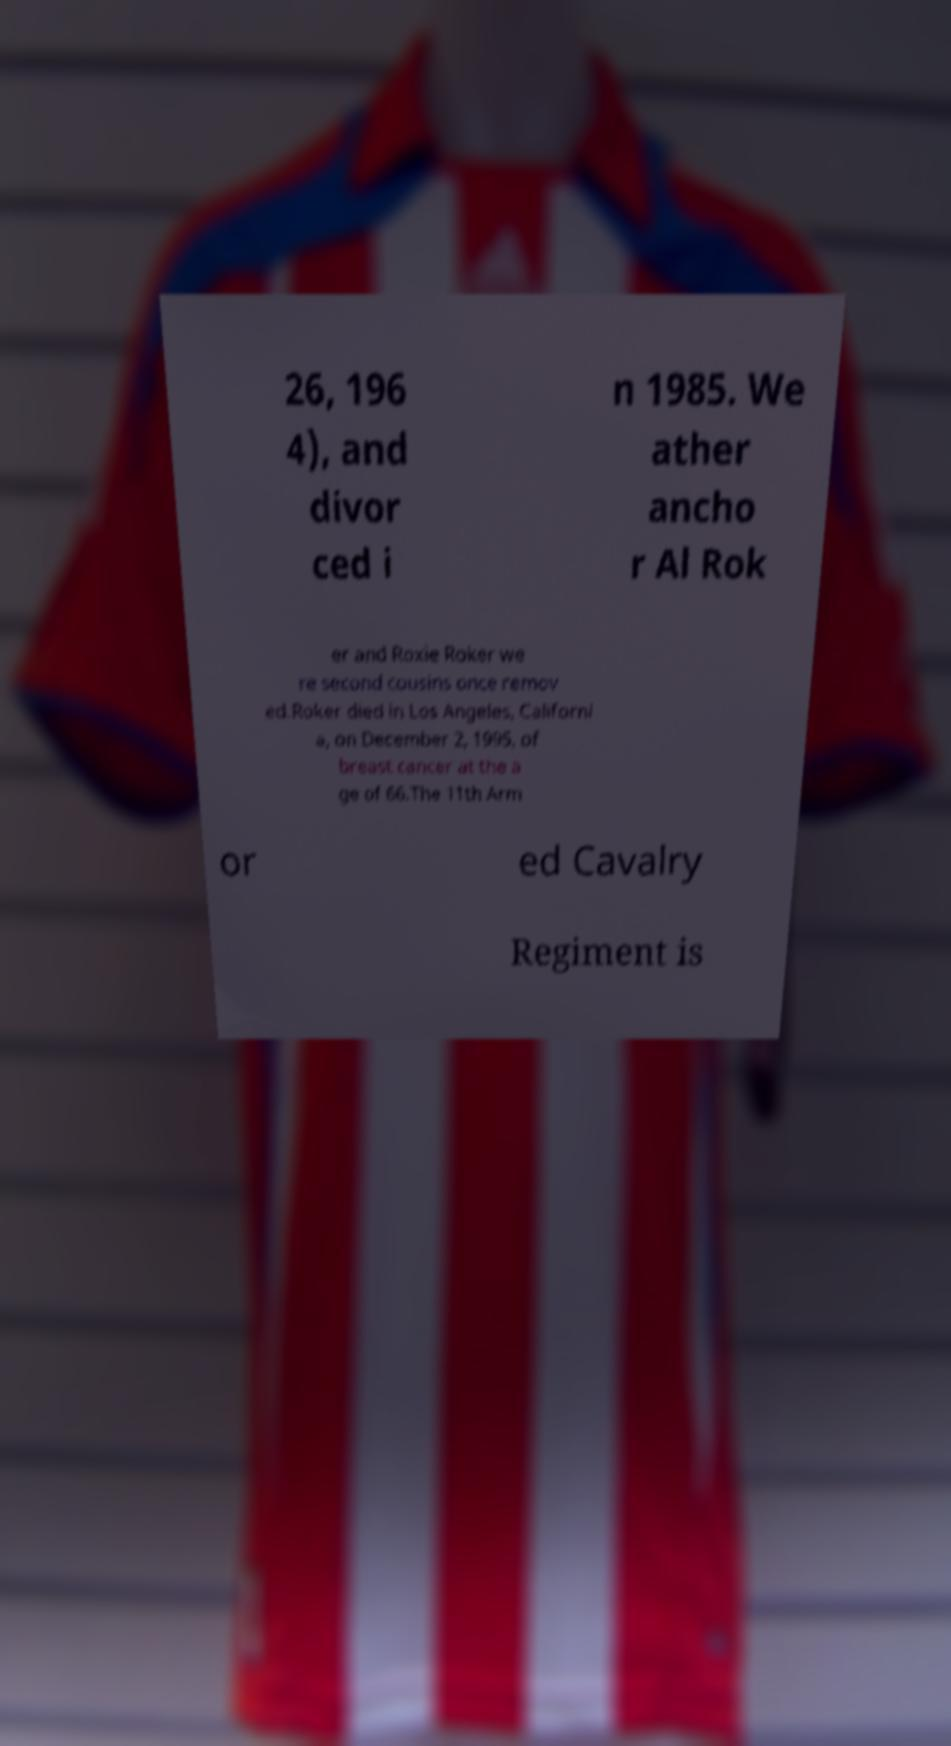Please identify and transcribe the text found in this image. 26, 196 4), and divor ced i n 1985. We ather ancho r Al Rok er and Roxie Roker we re second cousins once remov ed.Roker died in Los Angeles, Californi a, on December 2, 1995, of breast cancer at the a ge of 66.The 11th Arm or ed Cavalry Regiment is 